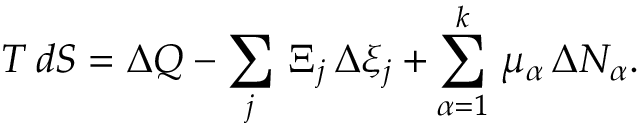<formula> <loc_0><loc_0><loc_500><loc_500>T \, d S = \Delta Q - \sum _ { j } \, \Xi _ { j } \, \Delta \xi _ { j } + \sum _ { \alpha = 1 } ^ { k } \, \mu _ { \alpha } \, \Delta N _ { \alpha } .</formula> 